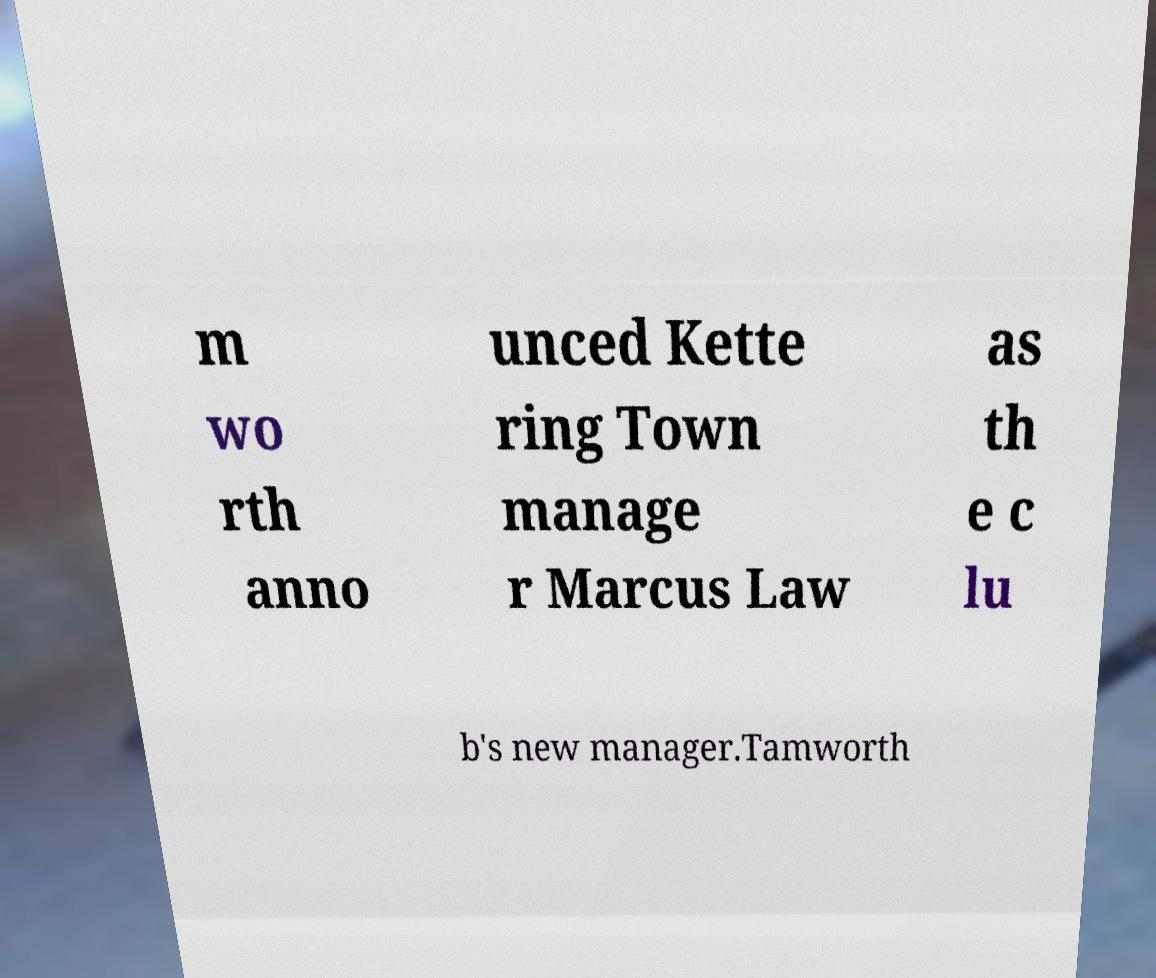For documentation purposes, I need the text within this image transcribed. Could you provide that? m wo rth anno unced Kette ring Town manage r Marcus Law as th e c lu b's new manager.Tamworth 